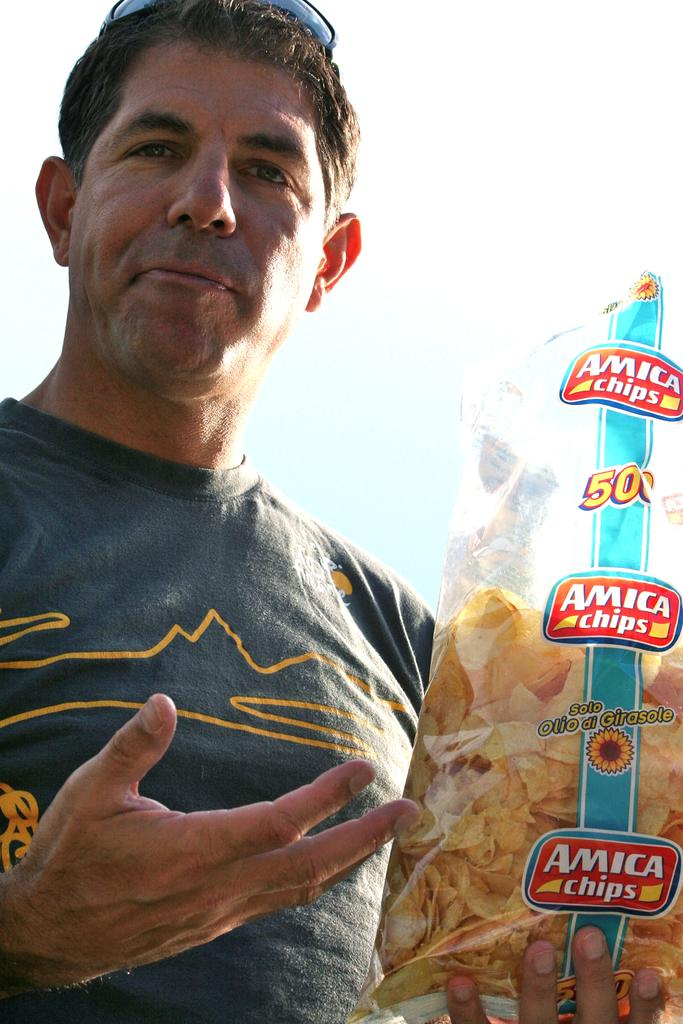Who is present in the image? There is a man in the image. What is the man wearing? The man is wearing a blue t-shirt. What is the man holding in the image? The man is holding a packet of chips. What can be seen at the top of the image? The sky is visible at the top of the image. Where is the kettle located in the image? There is no kettle present in the image. What type of love is being expressed in the image? There is no indication of love or any emotion being expressed in the image; it simply shows a man holding a packet of chips. 